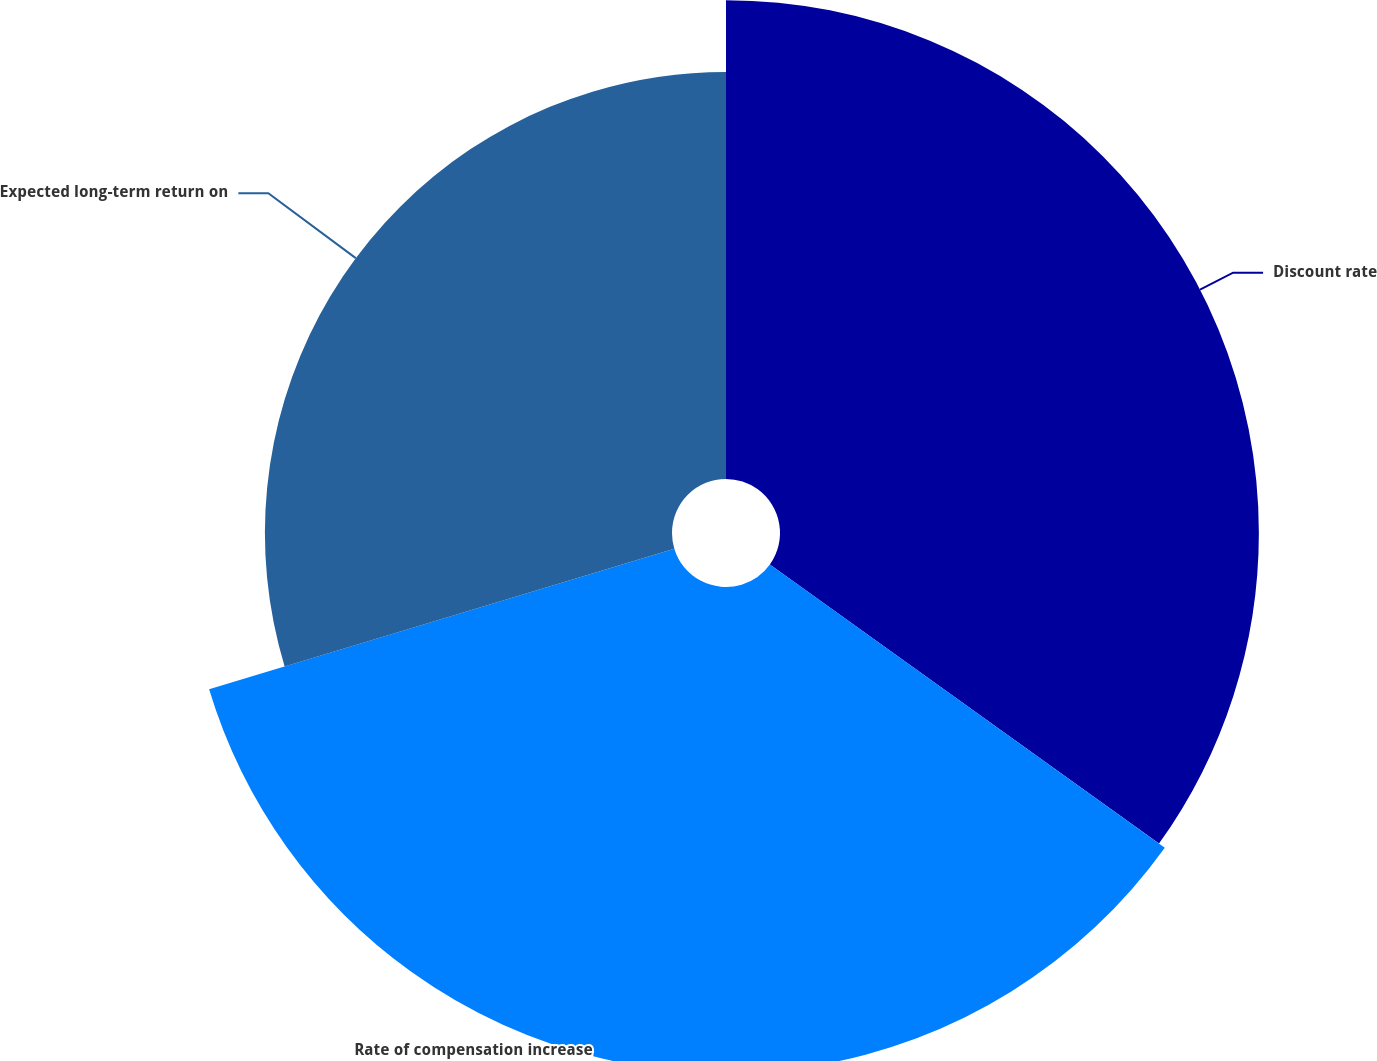<chart> <loc_0><loc_0><loc_500><loc_500><pie_chart><fcel>Discount rate<fcel>Rate of compensation increase<fcel>Expected long-term return on<nl><fcel>34.9%<fcel>35.42%<fcel>29.67%<nl></chart> 